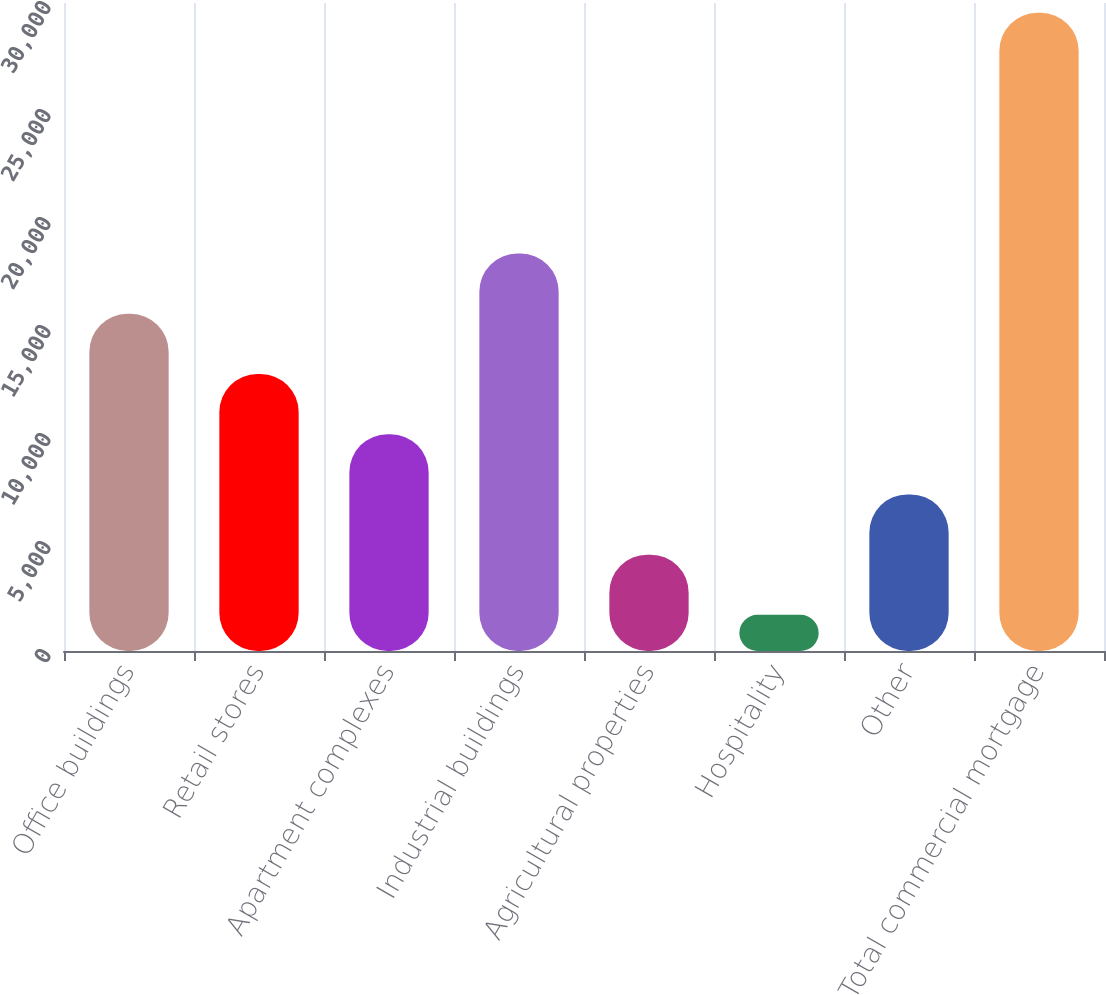Convert chart to OTSL. <chart><loc_0><loc_0><loc_500><loc_500><bar_chart><fcel>Office buildings<fcel>Retail stores<fcel>Apartment complexes<fcel>Industrial buildings<fcel>Agricultural properties<fcel>Hospitality<fcel>Other<fcel>Total commercial mortgage<nl><fcel>15610<fcel>12822.6<fcel>10035.2<fcel>18397.4<fcel>4460.4<fcel>1673<fcel>7247.8<fcel>29547<nl></chart> 